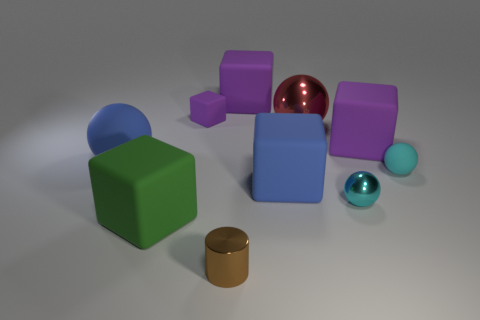Subtract all large blue spheres. How many spheres are left? 3 Subtract all red balls. How many balls are left? 3 Subtract 0 brown spheres. How many objects are left? 10 Subtract all cylinders. How many objects are left? 9 Subtract 2 balls. How many balls are left? 2 Subtract all blue blocks. Subtract all yellow cylinders. How many blocks are left? 4 Subtract all yellow cubes. How many red balls are left? 1 Subtract all big blue matte spheres. Subtract all large blue matte things. How many objects are left? 7 Add 9 red objects. How many red objects are left? 10 Add 2 big objects. How many big objects exist? 8 